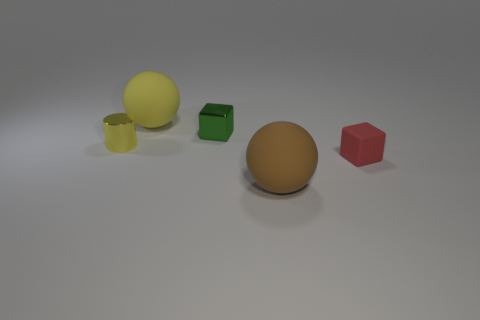Add 1 small metallic cylinders. How many objects exist? 6 Subtract all cubes. How many objects are left? 3 Add 3 green metal blocks. How many green metal blocks are left? 4 Add 5 tiny brown matte objects. How many tiny brown matte objects exist? 5 Subtract 1 brown spheres. How many objects are left? 4 Subtract all tiny yellow metallic cylinders. Subtract all brown matte spheres. How many objects are left? 3 